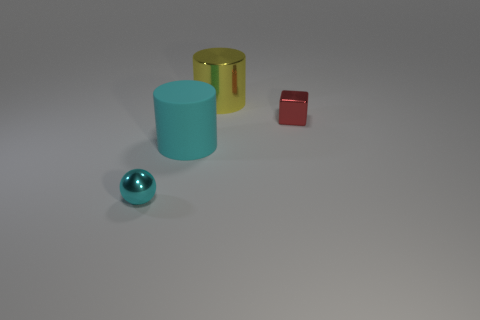Add 2 small objects. How many objects exist? 6 Subtract all cubes. How many objects are left? 3 Add 3 yellow shiny things. How many yellow shiny things exist? 4 Subtract 0 brown blocks. How many objects are left? 4 Subtract all tiny gray cubes. Subtract all metal cubes. How many objects are left? 3 Add 1 metal cubes. How many metal cubes are left? 2 